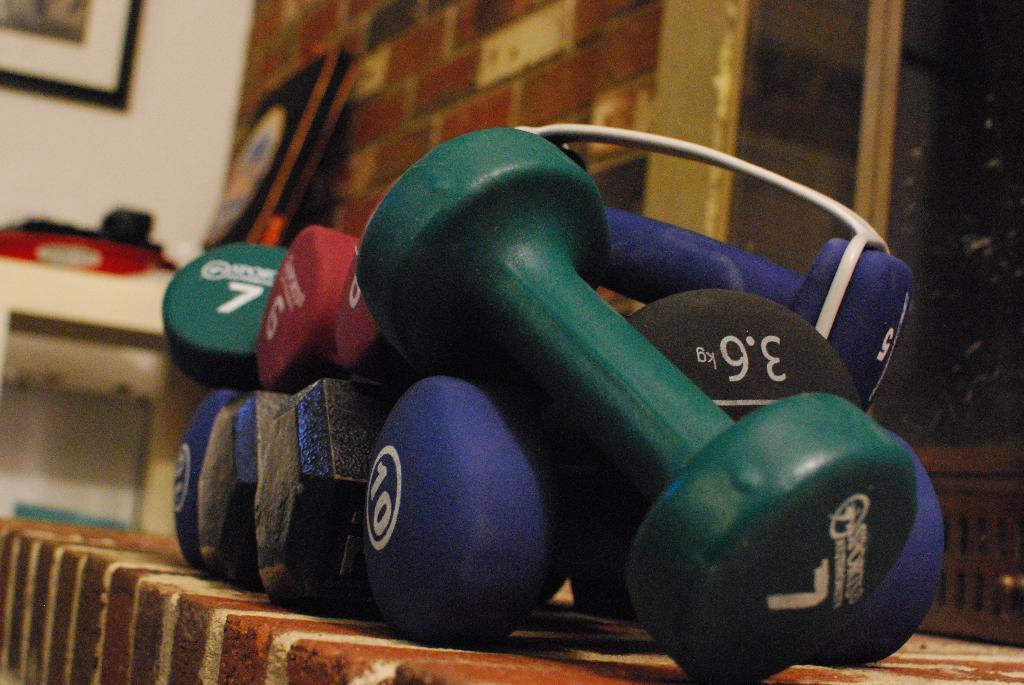Could you give a brief overview of what you see in this image? In the given image i can see a dumbbells. 